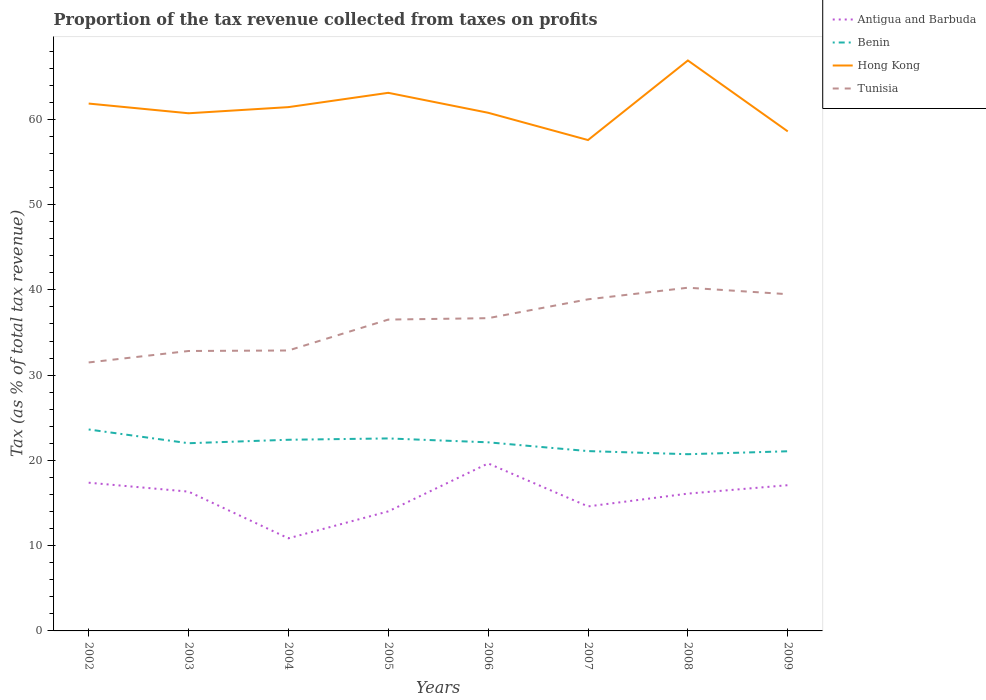Across all years, what is the maximum proportion of the tax revenue collected in Antigua and Barbuda?
Offer a very short reply. 10.86. In which year was the proportion of the tax revenue collected in Benin maximum?
Your response must be concise. 2008. What is the total proportion of the tax revenue collected in Hong Kong in the graph?
Your answer should be compact. 3.26. What is the difference between the highest and the second highest proportion of the tax revenue collected in Hong Kong?
Offer a terse response. 9.33. What is the difference between the highest and the lowest proportion of the tax revenue collected in Hong Kong?
Your answer should be very brief. 4. Is the proportion of the tax revenue collected in Antigua and Barbuda strictly greater than the proportion of the tax revenue collected in Hong Kong over the years?
Offer a terse response. Yes. How many years are there in the graph?
Provide a short and direct response. 8. Does the graph contain any zero values?
Make the answer very short. No. Where does the legend appear in the graph?
Provide a short and direct response. Top right. How many legend labels are there?
Your answer should be very brief. 4. How are the legend labels stacked?
Ensure brevity in your answer.  Vertical. What is the title of the graph?
Offer a very short reply. Proportion of the tax revenue collected from taxes on profits. Does "Armenia" appear as one of the legend labels in the graph?
Offer a terse response. No. What is the label or title of the X-axis?
Give a very brief answer. Years. What is the label or title of the Y-axis?
Your answer should be compact. Tax (as % of total tax revenue). What is the Tax (as % of total tax revenue) in Antigua and Barbuda in 2002?
Make the answer very short. 17.38. What is the Tax (as % of total tax revenue) of Benin in 2002?
Ensure brevity in your answer.  23.63. What is the Tax (as % of total tax revenue) in Hong Kong in 2002?
Your answer should be compact. 61.85. What is the Tax (as % of total tax revenue) in Tunisia in 2002?
Give a very brief answer. 31.49. What is the Tax (as % of total tax revenue) of Antigua and Barbuda in 2003?
Offer a terse response. 16.34. What is the Tax (as % of total tax revenue) of Benin in 2003?
Ensure brevity in your answer.  22.01. What is the Tax (as % of total tax revenue) in Hong Kong in 2003?
Provide a short and direct response. 60.71. What is the Tax (as % of total tax revenue) of Tunisia in 2003?
Ensure brevity in your answer.  32.83. What is the Tax (as % of total tax revenue) in Antigua and Barbuda in 2004?
Ensure brevity in your answer.  10.86. What is the Tax (as % of total tax revenue) in Benin in 2004?
Make the answer very short. 22.42. What is the Tax (as % of total tax revenue) in Hong Kong in 2004?
Offer a very short reply. 61.43. What is the Tax (as % of total tax revenue) of Tunisia in 2004?
Ensure brevity in your answer.  32.89. What is the Tax (as % of total tax revenue) in Antigua and Barbuda in 2005?
Your response must be concise. 14.02. What is the Tax (as % of total tax revenue) of Benin in 2005?
Your answer should be very brief. 22.58. What is the Tax (as % of total tax revenue) of Hong Kong in 2005?
Your response must be concise. 63.11. What is the Tax (as % of total tax revenue) in Tunisia in 2005?
Make the answer very short. 36.51. What is the Tax (as % of total tax revenue) in Antigua and Barbuda in 2006?
Your response must be concise. 19.64. What is the Tax (as % of total tax revenue) in Benin in 2006?
Your answer should be compact. 22.12. What is the Tax (as % of total tax revenue) in Hong Kong in 2006?
Your answer should be very brief. 60.77. What is the Tax (as % of total tax revenue) in Tunisia in 2006?
Your answer should be very brief. 36.68. What is the Tax (as % of total tax revenue) of Antigua and Barbuda in 2007?
Make the answer very short. 14.6. What is the Tax (as % of total tax revenue) in Benin in 2007?
Provide a short and direct response. 21.09. What is the Tax (as % of total tax revenue) in Hong Kong in 2007?
Ensure brevity in your answer.  57.57. What is the Tax (as % of total tax revenue) in Tunisia in 2007?
Keep it short and to the point. 38.89. What is the Tax (as % of total tax revenue) of Antigua and Barbuda in 2008?
Ensure brevity in your answer.  16.1. What is the Tax (as % of total tax revenue) of Benin in 2008?
Offer a terse response. 20.73. What is the Tax (as % of total tax revenue) of Hong Kong in 2008?
Your answer should be very brief. 66.9. What is the Tax (as % of total tax revenue) in Tunisia in 2008?
Your answer should be compact. 40.25. What is the Tax (as % of total tax revenue) of Antigua and Barbuda in 2009?
Keep it short and to the point. 17.09. What is the Tax (as % of total tax revenue) in Benin in 2009?
Your answer should be very brief. 21.07. What is the Tax (as % of total tax revenue) in Hong Kong in 2009?
Your answer should be very brief. 58.59. What is the Tax (as % of total tax revenue) of Tunisia in 2009?
Provide a short and direct response. 39.49. Across all years, what is the maximum Tax (as % of total tax revenue) in Antigua and Barbuda?
Your answer should be very brief. 19.64. Across all years, what is the maximum Tax (as % of total tax revenue) in Benin?
Make the answer very short. 23.63. Across all years, what is the maximum Tax (as % of total tax revenue) in Hong Kong?
Offer a very short reply. 66.9. Across all years, what is the maximum Tax (as % of total tax revenue) in Tunisia?
Offer a very short reply. 40.25. Across all years, what is the minimum Tax (as % of total tax revenue) in Antigua and Barbuda?
Your response must be concise. 10.86. Across all years, what is the minimum Tax (as % of total tax revenue) of Benin?
Keep it short and to the point. 20.73. Across all years, what is the minimum Tax (as % of total tax revenue) in Hong Kong?
Your response must be concise. 57.57. Across all years, what is the minimum Tax (as % of total tax revenue) in Tunisia?
Provide a succinct answer. 31.49. What is the total Tax (as % of total tax revenue) of Antigua and Barbuda in the graph?
Offer a very short reply. 126.05. What is the total Tax (as % of total tax revenue) in Benin in the graph?
Offer a very short reply. 175.64. What is the total Tax (as % of total tax revenue) of Hong Kong in the graph?
Ensure brevity in your answer.  490.93. What is the total Tax (as % of total tax revenue) in Tunisia in the graph?
Your answer should be compact. 289.03. What is the difference between the Tax (as % of total tax revenue) of Antigua and Barbuda in 2002 and that in 2003?
Provide a succinct answer. 1.05. What is the difference between the Tax (as % of total tax revenue) of Benin in 2002 and that in 2003?
Your answer should be very brief. 1.61. What is the difference between the Tax (as % of total tax revenue) of Hong Kong in 2002 and that in 2003?
Give a very brief answer. 1.14. What is the difference between the Tax (as % of total tax revenue) in Tunisia in 2002 and that in 2003?
Make the answer very short. -1.34. What is the difference between the Tax (as % of total tax revenue) of Antigua and Barbuda in 2002 and that in 2004?
Offer a terse response. 6.52. What is the difference between the Tax (as % of total tax revenue) in Benin in 2002 and that in 2004?
Keep it short and to the point. 1.21. What is the difference between the Tax (as % of total tax revenue) in Hong Kong in 2002 and that in 2004?
Keep it short and to the point. 0.42. What is the difference between the Tax (as % of total tax revenue) of Tunisia in 2002 and that in 2004?
Ensure brevity in your answer.  -1.4. What is the difference between the Tax (as % of total tax revenue) of Antigua and Barbuda in 2002 and that in 2005?
Provide a succinct answer. 3.36. What is the difference between the Tax (as % of total tax revenue) in Benin in 2002 and that in 2005?
Offer a very short reply. 1.05. What is the difference between the Tax (as % of total tax revenue) in Hong Kong in 2002 and that in 2005?
Give a very brief answer. -1.26. What is the difference between the Tax (as % of total tax revenue) of Tunisia in 2002 and that in 2005?
Give a very brief answer. -5.03. What is the difference between the Tax (as % of total tax revenue) of Antigua and Barbuda in 2002 and that in 2006?
Provide a succinct answer. -2.26. What is the difference between the Tax (as % of total tax revenue) of Benin in 2002 and that in 2006?
Offer a very short reply. 1.51. What is the difference between the Tax (as % of total tax revenue) of Hong Kong in 2002 and that in 2006?
Offer a terse response. 1.08. What is the difference between the Tax (as % of total tax revenue) in Tunisia in 2002 and that in 2006?
Your answer should be compact. -5.19. What is the difference between the Tax (as % of total tax revenue) of Antigua and Barbuda in 2002 and that in 2007?
Your response must be concise. 2.78. What is the difference between the Tax (as % of total tax revenue) of Benin in 2002 and that in 2007?
Offer a very short reply. 2.54. What is the difference between the Tax (as % of total tax revenue) in Hong Kong in 2002 and that in 2007?
Your answer should be compact. 4.28. What is the difference between the Tax (as % of total tax revenue) in Tunisia in 2002 and that in 2007?
Give a very brief answer. -7.4. What is the difference between the Tax (as % of total tax revenue) in Antigua and Barbuda in 2002 and that in 2008?
Keep it short and to the point. 1.28. What is the difference between the Tax (as % of total tax revenue) in Benin in 2002 and that in 2008?
Ensure brevity in your answer.  2.9. What is the difference between the Tax (as % of total tax revenue) in Hong Kong in 2002 and that in 2008?
Your answer should be compact. -5.05. What is the difference between the Tax (as % of total tax revenue) of Tunisia in 2002 and that in 2008?
Keep it short and to the point. -8.77. What is the difference between the Tax (as % of total tax revenue) in Antigua and Barbuda in 2002 and that in 2009?
Offer a very short reply. 0.29. What is the difference between the Tax (as % of total tax revenue) in Benin in 2002 and that in 2009?
Keep it short and to the point. 2.56. What is the difference between the Tax (as % of total tax revenue) in Hong Kong in 2002 and that in 2009?
Your answer should be very brief. 3.26. What is the difference between the Tax (as % of total tax revenue) of Tunisia in 2002 and that in 2009?
Offer a very short reply. -8. What is the difference between the Tax (as % of total tax revenue) of Antigua and Barbuda in 2003 and that in 2004?
Make the answer very short. 5.47. What is the difference between the Tax (as % of total tax revenue) in Benin in 2003 and that in 2004?
Offer a terse response. -0.41. What is the difference between the Tax (as % of total tax revenue) in Hong Kong in 2003 and that in 2004?
Keep it short and to the point. -0.72. What is the difference between the Tax (as % of total tax revenue) in Tunisia in 2003 and that in 2004?
Offer a very short reply. -0.06. What is the difference between the Tax (as % of total tax revenue) of Antigua and Barbuda in 2003 and that in 2005?
Provide a short and direct response. 2.31. What is the difference between the Tax (as % of total tax revenue) of Benin in 2003 and that in 2005?
Offer a very short reply. -0.56. What is the difference between the Tax (as % of total tax revenue) in Hong Kong in 2003 and that in 2005?
Provide a short and direct response. -2.4. What is the difference between the Tax (as % of total tax revenue) of Tunisia in 2003 and that in 2005?
Your answer should be very brief. -3.68. What is the difference between the Tax (as % of total tax revenue) in Antigua and Barbuda in 2003 and that in 2006?
Make the answer very short. -3.31. What is the difference between the Tax (as % of total tax revenue) of Benin in 2003 and that in 2006?
Ensure brevity in your answer.  -0.11. What is the difference between the Tax (as % of total tax revenue) of Hong Kong in 2003 and that in 2006?
Ensure brevity in your answer.  -0.06. What is the difference between the Tax (as % of total tax revenue) of Tunisia in 2003 and that in 2006?
Your answer should be very brief. -3.85. What is the difference between the Tax (as % of total tax revenue) in Antigua and Barbuda in 2003 and that in 2007?
Offer a very short reply. 1.73. What is the difference between the Tax (as % of total tax revenue) in Benin in 2003 and that in 2007?
Give a very brief answer. 0.92. What is the difference between the Tax (as % of total tax revenue) in Hong Kong in 2003 and that in 2007?
Keep it short and to the point. 3.14. What is the difference between the Tax (as % of total tax revenue) of Tunisia in 2003 and that in 2007?
Provide a short and direct response. -6.06. What is the difference between the Tax (as % of total tax revenue) in Antigua and Barbuda in 2003 and that in 2008?
Your answer should be very brief. 0.23. What is the difference between the Tax (as % of total tax revenue) of Benin in 2003 and that in 2008?
Your answer should be compact. 1.29. What is the difference between the Tax (as % of total tax revenue) in Hong Kong in 2003 and that in 2008?
Provide a succinct answer. -6.19. What is the difference between the Tax (as % of total tax revenue) in Tunisia in 2003 and that in 2008?
Offer a very short reply. -7.42. What is the difference between the Tax (as % of total tax revenue) in Antigua and Barbuda in 2003 and that in 2009?
Make the answer very short. -0.75. What is the difference between the Tax (as % of total tax revenue) of Benin in 2003 and that in 2009?
Your response must be concise. 0.94. What is the difference between the Tax (as % of total tax revenue) of Hong Kong in 2003 and that in 2009?
Keep it short and to the point. 2.13. What is the difference between the Tax (as % of total tax revenue) in Tunisia in 2003 and that in 2009?
Keep it short and to the point. -6.66. What is the difference between the Tax (as % of total tax revenue) in Antigua and Barbuda in 2004 and that in 2005?
Ensure brevity in your answer.  -3.16. What is the difference between the Tax (as % of total tax revenue) of Benin in 2004 and that in 2005?
Your answer should be very brief. -0.16. What is the difference between the Tax (as % of total tax revenue) in Hong Kong in 2004 and that in 2005?
Provide a succinct answer. -1.68. What is the difference between the Tax (as % of total tax revenue) in Tunisia in 2004 and that in 2005?
Keep it short and to the point. -3.62. What is the difference between the Tax (as % of total tax revenue) of Antigua and Barbuda in 2004 and that in 2006?
Your answer should be compact. -8.78. What is the difference between the Tax (as % of total tax revenue) in Benin in 2004 and that in 2006?
Offer a terse response. 0.3. What is the difference between the Tax (as % of total tax revenue) of Hong Kong in 2004 and that in 2006?
Your answer should be compact. 0.66. What is the difference between the Tax (as % of total tax revenue) of Tunisia in 2004 and that in 2006?
Provide a succinct answer. -3.79. What is the difference between the Tax (as % of total tax revenue) of Antigua and Barbuda in 2004 and that in 2007?
Make the answer very short. -3.74. What is the difference between the Tax (as % of total tax revenue) in Benin in 2004 and that in 2007?
Ensure brevity in your answer.  1.33. What is the difference between the Tax (as % of total tax revenue) of Hong Kong in 2004 and that in 2007?
Make the answer very short. 3.86. What is the difference between the Tax (as % of total tax revenue) of Tunisia in 2004 and that in 2007?
Your response must be concise. -6. What is the difference between the Tax (as % of total tax revenue) in Antigua and Barbuda in 2004 and that in 2008?
Your answer should be compact. -5.24. What is the difference between the Tax (as % of total tax revenue) of Benin in 2004 and that in 2008?
Provide a succinct answer. 1.69. What is the difference between the Tax (as % of total tax revenue) in Hong Kong in 2004 and that in 2008?
Your response must be concise. -5.47. What is the difference between the Tax (as % of total tax revenue) of Tunisia in 2004 and that in 2008?
Your answer should be compact. -7.36. What is the difference between the Tax (as % of total tax revenue) in Antigua and Barbuda in 2004 and that in 2009?
Your answer should be compact. -6.23. What is the difference between the Tax (as % of total tax revenue) of Benin in 2004 and that in 2009?
Keep it short and to the point. 1.35. What is the difference between the Tax (as % of total tax revenue) in Hong Kong in 2004 and that in 2009?
Offer a very short reply. 2.85. What is the difference between the Tax (as % of total tax revenue) of Tunisia in 2004 and that in 2009?
Provide a succinct answer. -6.6. What is the difference between the Tax (as % of total tax revenue) of Antigua and Barbuda in 2005 and that in 2006?
Give a very brief answer. -5.62. What is the difference between the Tax (as % of total tax revenue) in Benin in 2005 and that in 2006?
Provide a succinct answer. 0.46. What is the difference between the Tax (as % of total tax revenue) in Hong Kong in 2005 and that in 2006?
Ensure brevity in your answer.  2.34. What is the difference between the Tax (as % of total tax revenue) in Tunisia in 2005 and that in 2006?
Make the answer very short. -0.17. What is the difference between the Tax (as % of total tax revenue) of Antigua and Barbuda in 2005 and that in 2007?
Your answer should be compact. -0.58. What is the difference between the Tax (as % of total tax revenue) in Benin in 2005 and that in 2007?
Give a very brief answer. 1.48. What is the difference between the Tax (as % of total tax revenue) in Hong Kong in 2005 and that in 2007?
Your answer should be compact. 5.54. What is the difference between the Tax (as % of total tax revenue) of Tunisia in 2005 and that in 2007?
Make the answer very short. -2.38. What is the difference between the Tax (as % of total tax revenue) of Antigua and Barbuda in 2005 and that in 2008?
Give a very brief answer. -2.08. What is the difference between the Tax (as % of total tax revenue) of Benin in 2005 and that in 2008?
Keep it short and to the point. 1.85. What is the difference between the Tax (as % of total tax revenue) in Hong Kong in 2005 and that in 2008?
Provide a succinct answer. -3.79. What is the difference between the Tax (as % of total tax revenue) in Tunisia in 2005 and that in 2008?
Ensure brevity in your answer.  -3.74. What is the difference between the Tax (as % of total tax revenue) of Antigua and Barbuda in 2005 and that in 2009?
Make the answer very short. -3.07. What is the difference between the Tax (as % of total tax revenue) of Benin in 2005 and that in 2009?
Offer a very short reply. 1.51. What is the difference between the Tax (as % of total tax revenue) of Hong Kong in 2005 and that in 2009?
Provide a short and direct response. 4.52. What is the difference between the Tax (as % of total tax revenue) in Tunisia in 2005 and that in 2009?
Make the answer very short. -2.98. What is the difference between the Tax (as % of total tax revenue) in Antigua and Barbuda in 2006 and that in 2007?
Offer a very short reply. 5.04. What is the difference between the Tax (as % of total tax revenue) of Benin in 2006 and that in 2007?
Make the answer very short. 1.03. What is the difference between the Tax (as % of total tax revenue) in Hong Kong in 2006 and that in 2007?
Make the answer very short. 3.2. What is the difference between the Tax (as % of total tax revenue) in Tunisia in 2006 and that in 2007?
Your answer should be compact. -2.21. What is the difference between the Tax (as % of total tax revenue) of Antigua and Barbuda in 2006 and that in 2008?
Provide a short and direct response. 3.54. What is the difference between the Tax (as % of total tax revenue) in Benin in 2006 and that in 2008?
Provide a succinct answer. 1.39. What is the difference between the Tax (as % of total tax revenue) in Hong Kong in 2006 and that in 2008?
Make the answer very short. -6.13. What is the difference between the Tax (as % of total tax revenue) in Tunisia in 2006 and that in 2008?
Keep it short and to the point. -3.57. What is the difference between the Tax (as % of total tax revenue) of Antigua and Barbuda in 2006 and that in 2009?
Make the answer very short. 2.55. What is the difference between the Tax (as % of total tax revenue) of Benin in 2006 and that in 2009?
Offer a terse response. 1.05. What is the difference between the Tax (as % of total tax revenue) in Hong Kong in 2006 and that in 2009?
Provide a succinct answer. 2.18. What is the difference between the Tax (as % of total tax revenue) in Tunisia in 2006 and that in 2009?
Provide a succinct answer. -2.81. What is the difference between the Tax (as % of total tax revenue) in Antigua and Barbuda in 2007 and that in 2008?
Your answer should be very brief. -1.5. What is the difference between the Tax (as % of total tax revenue) of Benin in 2007 and that in 2008?
Your answer should be compact. 0.37. What is the difference between the Tax (as % of total tax revenue) in Hong Kong in 2007 and that in 2008?
Your answer should be compact. -9.33. What is the difference between the Tax (as % of total tax revenue) in Tunisia in 2007 and that in 2008?
Ensure brevity in your answer.  -1.36. What is the difference between the Tax (as % of total tax revenue) in Antigua and Barbuda in 2007 and that in 2009?
Keep it short and to the point. -2.49. What is the difference between the Tax (as % of total tax revenue) of Benin in 2007 and that in 2009?
Make the answer very short. 0.02. What is the difference between the Tax (as % of total tax revenue) of Hong Kong in 2007 and that in 2009?
Give a very brief answer. -1.02. What is the difference between the Tax (as % of total tax revenue) of Tunisia in 2007 and that in 2009?
Offer a terse response. -0.6. What is the difference between the Tax (as % of total tax revenue) in Antigua and Barbuda in 2008 and that in 2009?
Your answer should be compact. -0.99. What is the difference between the Tax (as % of total tax revenue) in Benin in 2008 and that in 2009?
Ensure brevity in your answer.  -0.34. What is the difference between the Tax (as % of total tax revenue) in Hong Kong in 2008 and that in 2009?
Offer a very short reply. 8.32. What is the difference between the Tax (as % of total tax revenue) of Tunisia in 2008 and that in 2009?
Give a very brief answer. 0.76. What is the difference between the Tax (as % of total tax revenue) in Antigua and Barbuda in 2002 and the Tax (as % of total tax revenue) in Benin in 2003?
Provide a short and direct response. -4.63. What is the difference between the Tax (as % of total tax revenue) of Antigua and Barbuda in 2002 and the Tax (as % of total tax revenue) of Hong Kong in 2003?
Ensure brevity in your answer.  -43.33. What is the difference between the Tax (as % of total tax revenue) in Antigua and Barbuda in 2002 and the Tax (as % of total tax revenue) in Tunisia in 2003?
Your response must be concise. -15.45. What is the difference between the Tax (as % of total tax revenue) in Benin in 2002 and the Tax (as % of total tax revenue) in Hong Kong in 2003?
Ensure brevity in your answer.  -37.09. What is the difference between the Tax (as % of total tax revenue) of Benin in 2002 and the Tax (as % of total tax revenue) of Tunisia in 2003?
Offer a terse response. -9.2. What is the difference between the Tax (as % of total tax revenue) of Hong Kong in 2002 and the Tax (as % of total tax revenue) of Tunisia in 2003?
Keep it short and to the point. 29.02. What is the difference between the Tax (as % of total tax revenue) of Antigua and Barbuda in 2002 and the Tax (as % of total tax revenue) of Benin in 2004?
Make the answer very short. -5.04. What is the difference between the Tax (as % of total tax revenue) in Antigua and Barbuda in 2002 and the Tax (as % of total tax revenue) in Hong Kong in 2004?
Your response must be concise. -44.05. What is the difference between the Tax (as % of total tax revenue) of Antigua and Barbuda in 2002 and the Tax (as % of total tax revenue) of Tunisia in 2004?
Your response must be concise. -15.51. What is the difference between the Tax (as % of total tax revenue) in Benin in 2002 and the Tax (as % of total tax revenue) in Hong Kong in 2004?
Give a very brief answer. -37.81. What is the difference between the Tax (as % of total tax revenue) of Benin in 2002 and the Tax (as % of total tax revenue) of Tunisia in 2004?
Keep it short and to the point. -9.26. What is the difference between the Tax (as % of total tax revenue) of Hong Kong in 2002 and the Tax (as % of total tax revenue) of Tunisia in 2004?
Give a very brief answer. 28.96. What is the difference between the Tax (as % of total tax revenue) of Antigua and Barbuda in 2002 and the Tax (as % of total tax revenue) of Benin in 2005?
Keep it short and to the point. -5.19. What is the difference between the Tax (as % of total tax revenue) in Antigua and Barbuda in 2002 and the Tax (as % of total tax revenue) in Hong Kong in 2005?
Your response must be concise. -45.73. What is the difference between the Tax (as % of total tax revenue) in Antigua and Barbuda in 2002 and the Tax (as % of total tax revenue) in Tunisia in 2005?
Offer a terse response. -19.13. What is the difference between the Tax (as % of total tax revenue) of Benin in 2002 and the Tax (as % of total tax revenue) of Hong Kong in 2005?
Provide a succinct answer. -39.48. What is the difference between the Tax (as % of total tax revenue) of Benin in 2002 and the Tax (as % of total tax revenue) of Tunisia in 2005?
Offer a very short reply. -12.89. What is the difference between the Tax (as % of total tax revenue) of Hong Kong in 2002 and the Tax (as % of total tax revenue) of Tunisia in 2005?
Your response must be concise. 25.33. What is the difference between the Tax (as % of total tax revenue) in Antigua and Barbuda in 2002 and the Tax (as % of total tax revenue) in Benin in 2006?
Keep it short and to the point. -4.74. What is the difference between the Tax (as % of total tax revenue) of Antigua and Barbuda in 2002 and the Tax (as % of total tax revenue) of Hong Kong in 2006?
Offer a terse response. -43.39. What is the difference between the Tax (as % of total tax revenue) in Antigua and Barbuda in 2002 and the Tax (as % of total tax revenue) in Tunisia in 2006?
Your answer should be very brief. -19.3. What is the difference between the Tax (as % of total tax revenue) of Benin in 2002 and the Tax (as % of total tax revenue) of Hong Kong in 2006?
Provide a succinct answer. -37.14. What is the difference between the Tax (as % of total tax revenue) of Benin in 2002 and the Tax (as % of total tax revenue) of Tunisia in 2006?
Ensure brevity in your answer.  -13.05. What is the difference between the Tax (as % of total tax revenue) in Hong Kong in 2002 and the Tax (as % of total tax revenue) in Tunisia in 2006?
Provide a succinct answer. 25.17. What is the difference between the Tax (as % of total tax revenue) of Antigua and Barbuda in 2002 and the Tax (as % of total tax revenue) of Benin in 2007?
Your answer should be compact. -3.71. What is the difference between the Tax (as % of total tax revenue) of Antigua and Barbuda in 2002 and the Tax (as % of total tax revenue) of Hong Kong in 2007?
Give a very brief answer. -40.19. What is the difference between the Tax (as % of total tax revenue) of Antigua and Barbuda in 2002 and the Tax (as % of total tax revenue) of Tunisia in 2007?
Keep it short and to the point. -21.51. What is the difference between the Tax (as % of total tax revenue) of Benin in 2002 and the Tax (as % of total tax revenue) of Hong Kong in 2007?
Give a very brief answer. -33.94. What is the difference between the Tax (as % of total tax revenue) of Benin in 2002 and the Tax (as % of total tax revenue) of Tunisia in 2007?
Your answer should be compact. -15.26. What is the difference between the Tax (as % of total tax revenue) of Hong Kong in 2002 and the Tax (as % of total tax revenue) of Tunisia in 2007?
Your response must be concise. 22.96. What is the difference between the Tax (as % of total tax revenue) of Antigua and Barbuda in 2002 and the Tax (as % of total tax revenue) of Benin in 2008?
Give a very brief answer. -3.34. What is the difference between the Tax (as % of total tax revenue) in Antigua and Barbuda in 2002 and the Tax (as % of total tax revenue) in Hong Kong in 2008?
Give a very brief answer. -49.52. What is the difference between the Tax (as % of total tax revenue) in Antigua and Barbuda in 2002 and the Tax (as % of total tax revenue) in Tunisia in 2008?
Your response must be concise. -22.87. What is the difference between the Tax (as % of total tax revenue) in Benin in 2002 and the Tax (as % of total tax revenue) in Hong Kong in 2008?
Offer a terse response. -43.28. What is the difference between the Tax (as % of total tax revenue) of Benin in 2002 and the Tax (as % of total tax revenue) of Tunisia in 2008?
Give a very brief answer. -16.63. What is the difference between the Tax (as % of total tax revenue) in Hong Kong in 2002 and the Tax (as % of total tax revenue) in Tunisia in 2008?
Make the answer very short. 21.6. What is the difference between the Tax (as % of total tax revenue) in Antigua and Barbuda in 2002 and the Tax (as % of total tax revenue) in Benin in 2009?
Make the answer very short. -3.69. What is the difference between the Tax (as % of total tax revenue) in Antigua and Barbuda in 2002 and the Tax (as % of total tax revenue) in Hong Kong in 2009?
Give a very brief answer. -41.2. What is the difference between the Tax (as % of total tax revenue) of Antigua and Barbuda in 2002 and the Tax (as % of total tax revenue) of Tunisia in 2009?
Provide a succinct answer. -22.11. What is the difference between the Tax (as % of total tax revenue) of Benin in 2002 and the Tax (as % of total tax revenue) of Hong Kong in 2009?
Your response must be concise. -34.96. What is the difference between the Tax (as % of total tax revenue) in Benin in 2002 and the Tax (as % of total tax revenue) in Tunisia in 2009?
Keep it short and to the point. -15.86. What is the difference between the Tax (as % of total tax revenue) of Hong Kong in 2002 and the Tax (as % of total tax revenue) of Tunisia in 2009?
Your answer should be very brief. 22.36. What is the difference between the Tax (as % of total tax revenue) in Antigua and Barbuda in 2003 and the Tax (as % of total tax revenue) in Benin in 2004?
Give a very brief answer. -6.08. What is the difference between the Tax (as % of total tax revenue) of Antigua and Barbuda in 2003 and the Tax (as % of total tax revenue) of Hong Kong in 2004?
Provide a succinct answer. -45.1. What is the difference between the Tax (as % of total tax revenue) of Antigua and Barbuda in 2003 and the Tax (as % of total tax revenue) of Tunisia in 2004?
Your answer should be very brief. -16.55. What is the difference between the Tax (as % of total tax revenue) of Benin in 2003 and the Tax (as % of total tax revenue) of Hong Kong in 2004?
Make the answer very short. -39.42. What is the difference between the Tax (as % of total tax revenue) in Benin in 2003 and the Tax (as % of total tax revenue) in Tunisia in 2004?
Your response must be concise. -10.88. What is the difference between the Tax (as % of total tax revenue) in Hong Kong in 2003 and the Tax (as % of total tax revenue) in Tunisia in 2004?
Make the answer very short. 27.82. What is the difference between the Tax (as % of total tax revenue) in Antigua and Barbuda in 2003 and the Tax (as % of total tax revenue) in Benin in 2005?
Make the answer very short. -6.24. What is the difference between the Tax (as % of total tax revenue) in Antigua and Barbuda in 2003 and the Tax (as % of total tax revenue) in Hong Kong in 2005?
Your response must be concise. -46.77. What is the difference between the Tax (as % of total tax revenue) of Antigua and Barbuda in 2003 and the Tax (as % of total tax revenue) of Tunisia in 2005?
Give a very brief answer. -20.18. What is the difference between the Tax (as % of total tax revenue) in Benin in 2003 and the Tax (as % of total tax revenue) in Hong Kong in 2005?
Your response must be concise. -41.1. What is the difference between the Tax (as % of total tax revenue) in Benin in 2003 and the Tax (as % of total tax revenue) in Tunisia in 2005?
Your response must be concise. -14.5. What is the difference between the Tax (as % of total tax revenue) of Hong Kong in 2003 and the Tax (as % of total tax revenue) of Tunisia in 2005?
Provide a short and direct response. 24.2. What is the difference between the Tax (as % of total tax revenue) of Antigua and Barbuda in 2003 and the Tax (as % of total tax revenue) of Benin in 2006?
Make the answer very short. -5.78. What is the difference between the Tax (as % of total tax revenue) of Antigua and Barbuda in 2003 and the Tax (as % of total tax revenue) of Hong Kong in 2006?
Offer a very short reply. -44.43. What is the difference between the Tax (as % of total tax revenue) of Antigua and Barbuda in 2003 and the Tax (as % of total tax revenue) of Tunisia in 2006?
Make the answer very short. -20.34. What is the difference between the Tax (as % of total tax revenue) in Benin in 2003 and the Tax (as % of total tax revenue) in Hong Kong in 2006?
Ensure brevity in your answer.  -38.76. What is the difference between the Tax (as % of total tax revenue) in Benin in 2003 and the Tax (as % of total tax revenue) in Tunisia in 2006?
Provide a short and direct response. -14.67. What is the difference between the Tax (as % of total tax revenue) of Hong Kong in 2003 and the Tax (as % of total tax revenue) of Tunisia in 2006?
Your answer should be very brief. 24.03. What is the difference between the Tax (as % of total tax revenue) in Antigua and Barbuda in 2003 and the Tax (as % of total tax revenue) in Benin in 2007?
Your response must be concise. -4.75. What is the difference between the Tax (as % of total tax revenue) of Antigua and Barbuda in 2003 and the Tax (as % of total tax revenue) of Hong Kong in 2007?
Your answer should be compact. -41.23. What is the difference between the Tax (as % of total tax revenue) in Antigua and Barbuda in 2003 and the Tax (as % of total tax revenue) in Tunisia in 2007?
Provide a succinct answer. -22.55. What is the difference between the Tax (as % of total tax revenue) in Benin in 2003 and the Tax (as % of total tax revenue) in Hong Kong in 2007?
Give a very brief answer. -35.56. What is the difference between the Tax (as % of total tax revenue) of Benin in 2003 and the Tax (as % of total tax revenue) of Tunisia in 2007?
Ensure brevity in your answer.  -16.88. What is the difference between the Tax (as % of total tax revenue) in Hong Kong in 2003 and the Tax (as % of total tax revenue) in Tunisia in 2007?
Your answer should be very brief. 21.82. What is the difference between the Tax (as % of total tax revenue) in Antigua and Barbuda in 2003 and the Tax (as % of total tax revenue) in Benin in 2008?
Ensure brevity in your answer.  -4.39. What is the difference between the Tax (as % of total tax revenue) of Antigua and Barbuda in 2003 and the Tax (as % of total tax revenue) of Hong Kong in 2008?
Provide a succinct answer. -50.57. What is the difference between the Tax (as % of total tax revenue) of Antigua and Barbuda in 2003 and the Tax (as % of total tax revenue) of Tunisia in 2008?
Provide a succinct answer. -23.92. What is the difference between the Tax (as % of total tax revenue) in Benin in 2003 and the Tax (as % of total tax revenue) in Hong Kong in 2008?
Make the answer very short. -44.89. What is the difference between the Tax (as % of total tax revenue) of Benin in 2003 and the Tax (as % of total tax revenue) of Tunisia in 2008?
Provide a succinct answer. -18.24. What is the difference between the Tax (as % of total tax revenue) in Hong Kong in 2003 and the Tax (as % of total tax revenue) in Tunisia in 2008?
Give a very brief answer. 20.46. What is the difference between the Tax (as % of total tax revenue) of Antigua and Barbuda in 2003 and the Tax (as % of total tax revenue) of Benin in 2009?
Your response must be concise. -4.73. What is the difference between the Tax (as % of total tax revenue) in Antigua and Barbuda in 2003 and the Tax (as % of total tax revenue) in Hong Kong in 2009?
Ensure brevity in your answer.  -42.25. What is the difference between the Tax (as % of total tax revenue) of Antigua and Barbuda in 2003 and the Tax (as % of total tax revenue) of Tunisia in 2009?
Ensure brevity in your answer.  -23.15. What is the difference between the Tax (as % of total tax revenue) of Benin in 2003 and the Tax (as % of total tax revenue) of Hong Kong in 2009?
Offer a terse response. -36.57. What is the difference between the Tax (as % of total tax revenue) in Benin in 2003 and the Tax (as % of total tax revenue) in Tunisia in 2009?
Your answer should be very brief. -17.48. What is the difference between the Tax (as % of total tax revenue) in Hong Kong in 2003 and the Tax (as % of total tax revenue) in Tunisia in 2009?
Make the answer very short. 21.22. What is the difference between the Tax (as % of total tax revenue) of Antigua and Barbuda in 2004 and the Tax (as % of total tax revenue) of Benin in 2005?
Your answer should be very brief. -11.71. What is the difference between the Tax (as % of total tax revenue) of Antigua and Barbuda in 2004 and the Tax (as % of total tax revenue) of Hong Kong in 2005?
Ensure brevity in your answer.  -52.25. What is the difference between the Tax (as % of total tax revenue) in Antigua and Barbuda in 2004 and the Tax (as % of total tax revenue) in Tunisia in 2005?
Your answer should be very brief. -25.65. What is the difference between the Tax (as % of total tax revenue) in Benin in 2004 and the Tax (as % of total tax revenue) in Hong Kong in 2005?
Offer a very short reply. -40.69. What is the difference between the Tax (as % of total tax revenue) of Benin in 2004 and the Tax (as % of total tax revenue) of Tunisia in 2005?
Provide a short and direct response. -14.1. What is the difference between the Tax (as % of total tax revenue) of Hong Kong in 2004 and the Tax (as % of total tax revenue) of Tunisia in 2005?
Your response must be concise. 24.92. What is the difference between the Tax (as % of total tax revenue) in Antigua and Barbuda in 2004 and the Tax (as % of total tax revenue) in Benin in 2006?
Your answer should be compact. -11.26. What is the difference between the Tax (as % of total tax revenue) in Antigua and Barbuda in 2004 and the Tax (as % of total tax revenue) in Hong Kong in 2006?
Make the answer very short. -49.91. What is the difference between the Tax (as % of total tax revenue) in Antigua and Barbuda in 2004 and the Tax (as % of total tax revenue) in Tunisia in 2006?
Your response must be concise. -25.82. What is the difference between the Tax (as % of total tax revenue) of Benin in 2004 and the Tax (as % of total tax revenue) of Hong Kong in 2006?
Offer a very short reply. -38.35. What is the difference between the Tax (as % of total tax revenue) in Benin in 2004 and the Tax (as % of total tax revenue) in Tunisia in 2006?
Provide a short and direct response. -14.26. What is the difference between the Tax (as % of total tax revenue) in Hong Kong in 2004 and the Tax (as % of total tax revenue) in Tunisia in 2006?
Make the answer very short. 24.75. What is the difference between the Tax (as % of total tax revenue) in Antigua and Barbuda in 2004 and the Tax (as % of total tax revenue) in Benin in 2007?
Your answer should be very brief. -10.23. What is the difference between the Tax (as % of total tax revenue) of Antigua and Barbuda in 2004 and the Tax (as % of total tax revenue) of Hong Kong in 2007?
Give a very brief answer. -46.71. What is the difference between the Tax (as % of total tax revenue) in Antigua and Barbuda in 2004 and the Tax (as % of total tax revenue) in Tunisia in 2007?
Keep it short and to the point. -28.03. What is the difference between the Tax (as % of total tax revenue) in Benin in 2004 and the Tax (as % of total tax revenue) in Hong Kong in 2007?
Your answer should be compact. -35.15. What is the difference between the Tax (as % of total tax revenue) in Benin in 2004 and the Tax (as % of total tax revenue) in Tunisia in 2007?
Ensure brevity in your answer.  -16.47. What is the difference between the Tax (as % of total tax revenue) of Hong Kong in 2004 and the Tax (as % of total tax revenue) of Tunisia in 2007?
Offer a terse response. 22.54. What is the difference between the Tax (as % of total tax revenue) in Antigua and Barbuda in 2004 and the Tax (as % of total tax revenue) in Benin in 2008?
Provide a succinct answer. -9.86. What is the difference between the Tax (as % of total tax revenue) in Antigua and Barbuda in 2004 and the Tax (as % of total tax revenue) in Hong Kong in 2008?
Provide a short and direct response. -56.04. What is the difference between the Tax (as % of total tax revenue) in Antigua and Barbuda in 2004 and the Tax (as % of total tax revenue) in Tunisia in 2008?
Make the answer very short. -29.39. What is the difference between the Tax (as % of total tax revenue) of Benin in 2004 and the Tax (as % of total tax revenue) of Hong Kong in 2008?
Your response must be concise. -44.48. What is the difference between the Tax (as % of total tax revenue) of Benin in 2004 and the Tax (as % of total tax revenue) of Tunisia in 2008?
Ensure brevity in your answer.  -17.83. What is the difference between the Tax (as % of total tax revenue) in Hong Kong in 2004 and the Tax (as % of total tax revenue) in Tunisia in 2008?
Give a very brief answer. 21.18. What is the difference between the Tax (as % of total tax revenue) in Antigua and Barbuda in 2004 and the Tax (as % of total tax revenue) in Benin in 2009?
Your response must be concise. -10.21. What is the difference between the Tax (as % of total tax revenue) of Antigua and Barbuda in 2004 and the Tax (as % of total tax revenue) of Hong Kong in 2009?
Ensure brevity in your answer.  -47.72. What is the difference between the Tax (as % of total tax revenue) in Antigua and Barbuda in 2004 and the Tax (as % of total tax revenue) in Tunisia in 2009?
Your answer should be compact. -28.63. What is the difference between the Tax (as % of total tax revenue) of Benin in 2004 and the Tax (as % of total tax revenue) of Hong Kong in 2009?
Offer a very short reply. -36.17. What is the difference between the Tax (as % of total tax revenue) in Benin in 2004 and the Tax (as % of total tax revenue) in Tunisia in 2009?
Your answer should be very brief. -17.07. What is the difference between the Tax (as % of total tax revenue) in Hong Kong in 2004 and the Tax (as % of total tax revenue) in Tunisia in 2009?
Provide a short and direct response. 21.94. What is the difference between the Tax (as % of total tax revenue) in Antigua and Barbuda in 2005 and the Tax (as % of total tax revenue) in Benin in 2006?
Offer a terse response. -8.1. What is the difference between the Tax (as % of total tax revenue) of Antigua and Barbuda in 2005 and the Tax (as % of total tax revenue) of Hong Kong in 2006?
Your answer should be compact. -46.75. What is the difference between the Tax (as % of total tax revenue) of Antigua and Barbuda in 2005 and the Tax (as % of total tax revenue) of Tunisia in 2006?
Your answer should be very brief. -22.66. What is the difference between the Tax (as % of total tax revenue) of Benin in 2005 and the Tax (as % of total tax revenue) of Hong Kong in 2006?
Your answer should be very brief. -38.19. What is the difference between the Tax (as % of total tax revenue) of Benin in 2005 and the Tax (as % of total tax revenue) of Tunisia in 2006?
Your answer should be very brief. -14.1. What is the difference between the Tax (as % of total tax revenue) in Hong Kong in 2005 and the Tax (as % of total tax revenue) in Tunisia in 2006?
Your answer should be compact. 26.43. What is the difference between the Tax (as % of total tax revenue) in Antigua and Barbuda in 2005 and the Tax (as % of total tax revenue) in Benin in 2007?
Make the answer very short. -7.07. What is the difference between the Tax (as % of total tax revenue) of Antigua and Barbuda in 2005 and the Tax (as % of total tax revenue) of Hong Kong in 2007?
Your response must be concise. -43.55. What is the difference between the Tax (as % of total tax revenue) of Antigua and Barbuda in 2005 and the Tax (as % of total tax revenue) of Tunisia in 2007?
Offer a terse response. -24.87. What is the difference between the Tax (as % of total tax revenue) of Benin in 2005 and the Tax (as % of total tax revenue) of Hong Kong in 2007?
Your answer should be very brief. -34.99. What is the difference between the Tax (as % of total tax revenue) in Benin in 2005 and the Tax (as % of total tax revenue) in Tunisia in 2007?
Give a very brief answer. -16.31. What is the difference between the Tax (as % of total tax revenue) of Hong Kong in 2005 and the Tax (as % of total tax revenue) of Tunisia in 2007?
Your response must be concise. 24.22. What is the difference between the Tax (as % of total tax revenue) in Antigua and Barbuda in 2005 and the Tax (as % of total tax revenue) in Benin in 2008?
Keep it short and to the point. -6.7. What is the difference between the Tax (as % of total tax revenue) in Antigua and Barbuda in 2005 and the Tax (as % of total tax revenue) in Hong Kong in 2008?
Provide a short and direct response. -52.88. What is the difference between the Tax (as % of total tax revenue) in Antigua and Barbuda in 2005 and the Tax (as % of total tax revenue) in Tunisia in 2008?
Provide a short and direct response. -26.23. What is the difference between the Tax (as % of total tax revenue) in Benin in 2005 and the Tax (as % of total tax revenue) in Hong Kong in 2008?
Your response must be concise. -44.33. What is the difference between the Tax (as % of total tax revenue) in Benin in 2005 and the Tax (as % of total tax revenue) in Tunisia in 2008?
Offer a very short reply. -17.68. What is the difference between the Tax (as % of total tax revenue) in Hong Kong in 2005 and the Tax (as % of total tax revenue) in Tunisia in 2008?
Offer a very short reply. 22.86. What is the difference between the Tax (as % of total tax revenue) in Antigua and Barbuda in 2005 and the Tax (as % of total tax revenue) in Benin in 2009?
Your answer should be very brief. -7.05. What is the difference between the Tax (as % of total tax revenue) of Antigua and Barbuda in 2005 and the Tax (as % of total tax revenue) of Hong Kong in 2009?
Give a very brief answer. -44.56. What is the difference between the Tax (as % of total tax revenue) in Antigua and Barbuda in 2005 and the Tax (as % of total tax revenue) in Tunisia in 2009?
Ensure brevity in your answer.  -25.47. What is the difference between the Tax (as % of total tax revenue) of Benin in 2005 and the Tax (as % of total tax revenue) of Hong Kong in 2009?
Give a very brief answer. -36.01. What is the difference between the Tax (as % of total tax revenue) in Benin in 2005 and the Tax (as % of total tax revenue) in Tunisia in 2009?
Offer a terse response. -16.91. What is the difference between the Tax (as % of total tax revenue) of Hong Kong in 2005 and the Tax (as % of total tax revenue) of Tunisia in 2009?
Provide a succinct answer. 23.62. What is the difference between the Tax (as % of total tax revenue) of Antigua and Barbuda in 2006 and the Tax (as % of total tax revenue) of Benin in 2007?
Provide a succinct answer. -1.45. What is the difference between the Tax (as % of total tax revenue) of Antigua and Barbuda in 2006 and the Tax (as % of total tax revenue) of Hong Kong in 2007?
Offer a very short reply. -37.93. What is the difference between the Tax (as % of total tax revenue) of Antigua and Barbuda in 2006 and the Tax (as % of total tax revenue) of Tunisia in 2007?
Provide a succinct answer. -19.25. What is the difference between the Tax (as % of total tax revenue) of Benin in 2006 and the Tax (as % of total tax revenue) of Hong Kong in 2007?
Your answer should be compact. -35.45. What is the difference between the Tax (as % of total tax revenue) of Benin in 2006 and the Tax (as % of total tax revenue) of Tunisia in 2007?
Give a very brief answer. -16.77. What is the difference between the Tax (as % of total tax revenue) of Hong Kong in 2006 and the Tax (as % of total tax revenue) of Tunisia in 2007?
Provide a short and direct response. 21.88. What is the difference between the Tax (as % of total tax revenue) of Antigua and Barbuda in 2006 and the Tax (as % of total tax revenue) of Benin in 2008?
Offer a very short reply. -1.08. What is the difference between the Tax (as % of total tax revenue) of Antigua and Barbuda in 2006 and the Tax (as % of total tax revenue) of Hong Kong in 2008?
Provide a succinct answer. -47.26. What is the difference between the Tax (as % of total tax revenue) of Antigua and Barbuda in 2006 and the Tax (as % of total tax revenue) of Tunisia in 2008?
Give a very brief answer. -20.61. What is the difference between the Tax (as % of total tax revenue) in Benin in 2006 and the Tax (as % of total tax revenue) in Hong Kong in 2008?
Keep it short and to the point. -44.78. What is the difference between the Tax (as % of total tax revenue) of Benin in 2006 and the Tax (as % of total tax revenue) of Tunisia in 2008?
Your answer should be very brief. -18.13. What is the difference between the Tax (as % of total tax revenue) in Hong Kong in 2006 and the Tax (as % of total tax revenue) in Tunisia in 2008?
Ensure brevity in your answer.  20.52. What is the difference between the Tax (as % of total tax revenue) of Antigua and Barbuda in 2006 and the Tax (as % of total tax revenue) of Benin in 2009?
Your response must be concise. -1.43. What is the difference between the Tax (as % of total tax revenue) of Antigua and Barbuda in 2006 and the Tax (as % of total tax revenue) of Hong Kong in 2009?
Give a very brief answer. -38.94. What is the difference between the Tax (as % of total tax revenue) in Antigua and Barbuda in 2006 and the Tax (as % of total tax revenue) in Tunisia in 2009?
Make the answer very short. -19.85. What is the difference between the Tax (as % of total tax revenue) of Benin in 2006 and the Tax (as % of total tax revenue) of Hong Kong in 2009?
Ensure brevity in your answer.  -36.47. What is the difference between the Tax (as % of total tax revenue) of Benin in 2006 and the Tax (as % of total tax revenue) of Tunisia in 2009?
Ensure brevity in your answer.  -17.37. What is the difference between the Tax (as % of total tax revenue) in Hong Kong in 2006 and the Tax (as % of total tax revenue) in Tunisia in 2009?
Make the answer very short. 21.28. What is the difference between the Tax (as % of total tax revenue) of Antigua and Barbuda in 2007 and the Tax (as % of total tax revenue) of Benin in 2008?
Give a very brief answer. -6.12. What is the difference between the Tax (as % of total tax revenue) of Antigua and Barbuda in 2007 and the Tax (as % of total tax revenue) of Hong Kong in 2008?
Provide a succinct answer. -52.3. What is the difference between the Tax (as % of total tax revenue) of Antigua and Barbuda in 2007 and the Tax (as % of total tax revenue) of Tunisia in 2008?
Your answer should be very brief. -25.65. What is the difference between the Tax (as % of total tax revenue) of Benin in 2007 and the Tax (as % of total tax revenue) of Hong Kong in 2008?
Ensure brevity in your answer.  -45.81. What is the difference between the Tax (as % of total tax revenue) of Benin in 2007 and the Tax (as % of total tax revenue) of Tunisia in 2008?
Your answer should be very brief. -19.16. What is the difference between the Tax (as % of total tax revenue) in Hong Kong in 2007 and the Tax (as % of total tax revenue) in Tunisia in 2008?
Your answer should be very brief. 17.32. What is the difference between the Tax (as % of total tax revenue) of Antigua and Barbuda in 2007 and the Tax (as % of total tax revenue) of Benin in 2009?
Provide a short and direct response. -6.47. What is the difference between the Tax (as % of total tax revenue) of Antigua and Barbuda in 2007 and the Tax (as % of total tax revenue) of Hong Kong in 2009?
Ensure brevity in your answer.  -43.98. What is the difference between the Tax (as % of total tax revenue) in Antigua and Barbuda in 2007 and the Tax (as % of total tax revenue) in Tunisia in 2009?
Your answer should be compact. -24.89. What is the difference between the Tax (as % of total tax revenue) in Benin in 2007 and the Tax (as % of total tax revenue) in Hong Kong in 2009?
Provide a short and direct response. -37.49. What is the difference between the Tax (as % of total tax revenue) in Benin in 2007 and the Tax (as % of total tax revenue) in Tunisia in 2009?
Offer a very short reply. -18.4. What is the difference between the Tax (as % of total tax revenue) of Hong Kong in 2007 and the Tax (as % of total tax revenue) of Tunisia in 2009?
Your answer should be compact. 18.08. What is the difference between the Tax (as % of total tax revenue) in Antigua and Barbuda in 2008 and the Tax (as % of total tax revenue) in Benin in 2009?
Ensure brevity in your answer.  -4.97. What is the difference between the Tax (as % of total tax revenue) in Antigua and Barbuda in 2008 and the Tax (as % of total tax revenue) in Hong Kong in 2009?
Provide a short and direct response. -42.48. What is the difference between the Tax (as % of total tax revenue) of Antigua and Barbuda in 2008 and the Tax (as % of total tax revenue) of Tunisia in 2009?
Provide a short and direct response. -23.39. What is the difference between the Tax (as % of total tax revenue) in Benin in 2008 and the Tax (as % of total tax revenue) in Hong Kong in 2009?
Offer a terse response. -37.86. What is the difference between the Tax (as % of total tax revenue) in Benin in 2008 and the Tax (as % of total tax revenue) in Tunisia in 2009?
Provide a succinct answer. -18.76. What is the difference between the Tax (as % of total tax revenue) in Hong Kong in 2008 and the Tax (as % of total tax revenue) in Tunisia in 2009?
Ensure brevity in your answer.  27.41. What is the average Tax (as % of total tax revenue) of Antigua and Barbuda per year?
Make the answer very short. 15.76. What is the average Tax (as % of total tax revenue) in Benin per year?
Your response must be concise. 21.95. What is the average Tax (as % of total tax revenue) in Hong Kong per year?
Give a very brief answer. 61.37. What is the average Tax (as % of total tax revenue) of Tunisia per year?
Give a very brief answer. 36.13. In the year 2002, what is the difference between the Tax (as % of total tax revenue) in Antigua and Barbuda and Tax (as % of total tax revenue) in Benin?
Offer a terse response. -6.24. In the year 2002, what is the difference between the Tax (as % of total tax revenue) of Antigua and Barbuda and Tax (as % of total tax revenue) of Hong Kong?
Offer a very short reply. -44.47. In the year 2002, what is the difference between the Tax (as % of total tax revenue) of Antigua and Barbuda and Tax (as % of total tax revenue) of Tunisia?
Your response must be concise. -14.1. In the year 2002, what is the difference between the Tax (as % of total tax revenue) in Benin and Tax (as % of total tax revenue) in Hong Kong?
Keep it short and to the point. -38.22. In the year 2002, what is the difference between the Tax (as % of total tax revenue) of Benin and Tax (as % of total tax revenue) of Tunisia?
Your answer should be very brief. -7.86. In the year 2002, what is the difference between the Tax (as % of total tax revenue) of Hong Kong and Tax (as % of total tax revenue) of Tunisia?
Offer a very short reply. 30.36. In the year 2003, what is the difference between the Tax (as % of total tax revenue) in Antigua and Barbuda and Tax (as % of total tax revenue) in Benin?
Your answer should be compact. -5.68. In the year 2003, what is the difference between the Tax (as % of total tax revenue) of Antigua and Barbuda and Tax (as % of total tax revenue) of Hong Kong?
Your answer should be compact. -44.38. In the year 2003, what is the difference between the Tax (as % of total tax revenue) in Antigua and Barbuda and Tax (as % of total tax revenue) in Tunisia?
Your answer should be compact. -16.49. In the year 2003, what is the difference between the Tax (as % of total tax revenue) of Benin and Tax (as % of total tax revenue) of Hong Kong?
Keep it short and to the point. -38.7. In the year 2003, what is the difference between the Tax (as % of total tax revenue) in Benin and Tax (as % of total tax revenue) in Tunisia?
Your answer should be very brief. -10.82. In the year 2003, what is the difference between the Tax (as % of total tax revenue) of Hong Kong and Tax (as % of total tax revenue) of Tunisia?
Ensure brevity in your answer.  27.88. In the year 2004, what is the difference between the Tax (as % of total tax revenue) in Antigua and Barbuda and Tax (as % of total tax revenue) in Benin?
Your answer should be very brief. -11.56. In the year 2004, what is the difference between the Tax (as % of total tax revenue) in Antigua and Barbuda and Tax (as % of total tax revenue) in Hong Kong?
Your answer should be compact. -50.57. In the year 2004, what is the difference between the Tax (as % of total tax revenue) of Antigua and Barbuda and Tax (as % of total tax revenue) of Tunisia?
Offer a very short reply. -22.03. In the year 2004, what is the difference between the Tax (as % of total tax revenue) in Benin and Tax (as % of total tax revenue) in Hong Kong?
Offer a terse response. -39.01. In the year 2004, what is the difference between the Tax (as % of total tax revenue) of Benin and Tax (as % of total tax revenue) of Tunisia?
Give a very brief answer. -10.47. In the year 2004, what is the difference between the Tax (as % of total tax revenue) in Hong Kong and Tax (as % of total tax revenue) in Tunisia?
Provide a short and direct response. 28.54. In the year 2005, what is the difference between the Tax (as % of total tax revenue) in Antigua and Barbuda and Tax (as % of total tax revenue) in Benin?
Your answer should be very brief. -8.55. In the year 2005, what is the difference between the Tax (as % of total tax revenue) in Antigua and Barbuda and Tax (as % of total tax revenue) in Hong Kong?
Your answer should be very brief. -49.09. In the year 2005, what is the difference between the Tax (as % of total tax revenue) in Antigua and Barbuda and Tax (as % of total tax revenue) in Tunisia?
Give a very brief answer. -22.49. In the year 2005, what is the difference between the Tax (as % of total tax revenue) of Benin and Tax (as % of total tax revenue) of Hong Kong?
Provide a succinct answer. -40.53. In the year 2005, what is the difference between the Tax (as % of total tax revenue) in Benin and Tax (as % of total tax revenue) in Tunisia?
Ensure brevity in your answer.  -13.94. In the year 2005, what is the difference between the Tax (as % of total tax revenue) in Hong Kong and Tax (as % of total tax revenue) in Tunisia?
Ensure brevity in your answer.  26.59. In the year 2006, what is the difference between the Tax (as % of total tax revenue) of Antigua and Barbuda and Tax (as % of total tax revenue) of Benin?
Provide a short and direct response. -2.47. In the year 2006, what is the difference between the Tax (as % of total tax revenue) in Antigua and Barbuda and Tax (as % of total tax revenue) in Hong Kong?
Your answer should be very brief. -41.13. In the year 2006, what is the difference between the Tax (as % of total tax revenue) of Antigua and Barbuda and Tax (as % of total tax revenue) of Tunisia?
Make the answer very short. -17.04. In the year 2006, what is the difference between the Tax (as % of total tax revenue) of Benin and Tax (as % of total tax revenue) of Hong Kong?
Ensure brevity in your answer.  -38.65. In the year 2006, what is the difference between the Tax (as % of total tax revenue) of Benin and Tax (as % of total tax revenue) of Tunisia?
Ensure brevity in your answer.  -14.56. In the year 2006, what is the difference between the Tax (as % of total tax revenue) of Hong Kong and Tax (as % of total tax revenue) of Tunisia?
Provide a succinct answer. 24.09. In the year 2007, what is the difference between the Tax (as % of total tax revenue) of Antigua and Barbuda and Tax (as % of total tax revenue) of Benin?
Your response must be concise. -6.49. In the year 2007, what is the difference between the Tax (as % of total tax revenue) of Antigua and Barbuda and Tax (as % of total tax revenue) of Hong Kong?
Keep it short and to the point. -42.97. In the year 2007, what is the difference between the Tax (as % of total tax revenue) in Antigua and Barbuda and Tax (as % of total tax revenue) in Tunisia?
Offer a very short reply. -24.29. In the year 2007, what is the difference between the Tax (as % of total tax revenue) of Benin and Tax (as % of total tax revenue) of Hong Kong?
Provide a short and direct response. -36.48. In the year 2007, what is the difference between the Tax (as % of total tax revenue) of Benin and Tax (as % of total tax revenue) of Tunisia?
Provide a short and direct response. -17.8. In the year 2007, what is the difference between the Tax (as % of total tax revenue) of Hong Kong and Tax (as % of total tax revenue) of Tunisia?
Provide a short and direct response. 18.68. In the year 2008, what is the difference between the Tax (as % of total tax revenue) in Antigua and Barbuda and Tax (as % of total tax revenue) in Benin?
Ensure brevity in your answer.  -4.62. In the year 2008, what is the difference between the Tax (as % of total tax revenue) in Antigua and Barbuda and Tax (as % of total tax revenue) in Hong Kong?
Your answer should be very brief. -50.8. In the year 2008, what is the difference between the Tax (as % of total tax revenue) of Antigua and Barbuda and Tax (as % of total tax revenue) of Tunisia?
Give a very brief answer. -24.15. In the year 2008, what is the difference between the Tax (as % of total tax revenue) in Benin and Tax (as % of total tax revenue) in Hong Kong?
Your response must be concise. -46.18. In the year 2008, what is the difference between the Tax (as % of total tax revenue) of Benin and Tax (as % of total tax revenue) of Tunisia?
Give a very brief answer. -19.53. In the year 2008, what is the difference between the Tax (as % of total tax revenue) in Hong Kong and Tax (as % of total tax revenue) in Tunisia?
Ensure brevity in your answer.  26.65. In the year 2009, what is the difference between the Tax (as % of total tax revenue) of Antigua and Barbuda and Tax (as % of total tax revenue) of Benin?
Ensure brevity in your answer.  -3.98. In the year 2009, what is the difference between the Tax (as % of total tax revenue) in Antigua and Barbuda and Tax (as % of total tax revenue) in Hong Kong?
Your answer should be compact. -41.49. In the year 2009, what is the difference between the Tax (as % of total tax revenue) in Antigua and Barbuda and Tax (as % of total tax revenue) in Tunisia?
Make the answer very short. -22.4. In the year 2009, what is the difference between the Tax (as % of total tax revenue) of Benin and Tax (as % of total tax revenue) of Hong Kong?
Ensure brevity in your answer.  -37.52. In the year 2009, what is the difference between the Tax (as % of total tax revenue) in Benin and Tax (as % of total tax revenue) in Tunisia?
Provide a short and direct response. -18.42. In the year 2009, what is the difference between the Tax (as % of total tax revenue) of Hong Kong and Tax (as % of total tax revenue) of Tunisia?
Provide a succinct answer. 19.1. What is the ratio of the Tax (as % of total tax revenue) of Antigua and Barbuda in 2002 to that in 2003?
Offer a very short reply. 1.06. What is the ratio of the Tax (as % of total tax revenue) in Benin in 2002 to that in 2003?
Give a very brief answer. 1.07. What is the ratio of the Tax (as % of total tax revenue) in Hong Kong in 2002 to that in 2003?
Your response must be concise. 1.02. What is the ratio of the Tax (as % of total tax revenue) in Tunisia in 2002 to that in 2003?
Offer a terse response. 0.96. What is the ratio of the Tax (as % of total tax revenue) of Antigua and Barbuda in 2002 to that in 2004?
Provide a short and direct response. 1.6. What is the ratio of the Tax (as % of total tax revenue) in Benin in 2002 to that in 2004?
Ensure brevity in your answer.  1.05. What is the ratio of the Tax (as % of total tax revenue) of Hong Kong in 2002 to that in 2004?
Keep it short and to the point. 1.01. What is the ratio of the Tax (as % of total tax revenue) in Tunisia in 2002 to that in 2004?
Provide a succinct answer. 0.96. What is the ratio of the Tax (as % of total tax revenue) of Antigua and Barbuda in 2002 to that in 2005?
Your response must be concise. 1.24. What is the ratio of the Tax (as % of total tax revenue) in Benin in 2002 to that in 2005?
Make the answer very short. 1.05. What is the ratio of the Tax (as % of total tax revenue) in Hong Kong in 2002 to that in 2005?
Ensure brevity in your answer.  0.98. What is the ratio of the Tax (as % of total tax revenue) of Tunisia in 2002 to that in 2005?
Your answer should be compact. 0.86. What is the ratio of the Tax (as % of total tax revenue) in Antigua and Barbuda in 2002 to that in 2006?
Ensure brevity in your answer.  0.88. What is the ratio of the Tax (as % of total tax revenue) in Benin in 2002 to that in 2006?
Your answer should be compact. 1.07. What is the ratio of the Tax (as % of total tax revenue) of Hong Kong in 2002 to that in 2006?
Your answer should be compact. 1.02. What is the ratio of the Tax (as % of total tax revenue) of Tunisia in 2002 to that in 2006?
Make the answer very short. 0.86. What is the ratio of the Tax (as % of total tax revenue) of Antigua and Barbuda in 2002 to that in 2007?
Provide a short and direct response. 1.19. What is the ratio of the Tax (as % of total tax revenue) of Benin in 2002 to that in 2007?
Your answer should be compact. 1.12. What is the ratio of the Tax (as % of total tax revenue) in Hong Kong in 2002 to that in 2007?
Your response must be concise. 1.07. What is the ratio of the Tax (as % of total tax revenue) of Tunisia in 2002 to that in 2007?
Your answer should be compact. 0.81. What is the ratio of the Tax (as % of total tax revenue) of Antigua and Barbuda in 2002 to that in 2008?
Provide a succinct answer. 1.08. What is the ratio of the Tax (as % of total tax revenue) of Benin in 2002 to that in 2008?
Your answer should be compact. 1.14. What is the ratio of the Tax (as % of total tax revenue) in Hong Kong in 2002 to that in 2008?
Your answer should be compact. 0.92. What is the ratio of the Tax (as % of total tax revenue) of Tunisia in 2002 to that in 2008?
Your answer should be compact. 0.78. What is the ratio of the Tax (as % of total tax revenue) of Antigua and Barbuda in 2002 to that in 2009?
Offer a terse response. 1.02. What is the ratio of the Tax (as % of total tax revenue) in Benin in 2002 to that in 2009?
Make the answer very short. 1.12. What is the ratio of the Tax (as % of total tax revenue) of Hong Kong in 2002 to that in 2009?
Your response must be concise. 1.06. What is the ratio of the Tax (as % of total tax revenue) in Tunisia in 2002 to that in 2009?
Ensure brevity in your answer.  0.8. What is the ratio of the Tax (as % of total tax revenue) of Antigua and Barbuda in 2003 to that in 2004?
Your response must be concise. 1.5. What is the ratio of the Tax (as % of total tax revenue) in Benin in 2003 to that in 2004?
Offer a very short reply. 0.98. What is the ratio of the Tax (as % of total tax revenue) in Hong Kong in 2003 to that in 2004?
Make the answer very short. 0.99. What is the ratio of the Tax (as % of total tax revenue) of Tunisia in 2003 to that in 2004?
Your response must be concise. 1. What is the ratio of the Tax (as % of total tax revenue) of Antigua and Barbuda in 2003 to that in 2005?
Ensure brevity in your answer.  1.17. What is the ratio of the Tax (as % of total tax revenue) in Benin in 2003 to that in 2005?
Ensure brevity in your answer.  0.98. What is the ratio of the Tax (as % of total tax revenue) of Tunisia in 2003 to that in 2005?
Your response must be concise. 0.9. What is the ratio of the Tax (as % of total tax revenue) in Antigua and Barbuda in 2003 to that in 2006?
Your answer should be compact. 0.83. What is the ratio of the Tax (as % of total tax revenue) in Benin in 2003 to that in 2006?
Offer a very short reply. 1. What is the ratio of the Tax (as % of total tax revenue) of Tunisia in 2003 to that in 2006?
Your answer should be very brief. 0.9. What is the ratio of the Tax (as % of total tax revenue) in Antigua and Barbuda in 2003 to that in 2007?
Provide a short and direct response. 1.12. What is the ratio of the Tax (as % of total tax revenue) in Benin in 2003 to that in 2007?
Provide a short and direct response. 1.04. What is the ratio of the Tax (as % of total tax revenue) in Hong Kong in 2003 to that in 2007?
Offer a very short reply. 1.05. What is the ratio of the Tax (as % of total tax revenue) in Tunisia in 2003 to that in 2007?
Your answer should be very brief. 0.84. What is the ratio of the Tax (as % of total tax revenue) of Antigua and Barbuda in 2003 to that in 2008?
Keep it short and to the point. 1.01. What is the ratio of the Tax (as % of total tax revenue) in Benin in 2003 to that in 2008?
Offer a very short reply. 1.06. What is the ratio of the Tax (as % of total tax revenue) of Hong Kong in 2003 to that in 2008?
Your answer should be compact. 0.91. What is the ratio of the Tax (as % of total tax revenue) in Tunisia in 2003 to that in 2008?
Your answer should be very brief. 0.82. What is the ratio of the Tax (as % of total tax revenue) in Antigua and Barbuda in 2003 to that in 2009?
Give a very brief answer. 0.96. What is the ratio of the Tax (as % of total tax revenue) in Benin in 2003 to that in 2009?
Provide a succinct answer. 1.04. What is the ratio of the Tax (as % of total tax revenue) in Hong Kong in 2003 to that in 2009?
Make the answer very short. 1.04. What is the ratio of the Tax (as % of total tax revenue) in Tunisia in 2003 to that in 2009?
Ensure brevity in your answer.  0.83. What is the ratio of the Tax (as % of total tax revenue) in Antigua and Barbuda in 2004 to that in 2005?
Offer a very short reply. 0.77. What is the ratio of the Tax (as % of total tax revenue) of Hong Kong in 2004 to that in 2005?
Keep it short and to the point. 0.97. What is the ratio of the Tax (as % of total tax revenue) of Tunisia in 2004 to that in 2005?
Give a very brief answer. 0.9. What is the ratio of the Tax (as % of total tax revenue) in Antigua and Barbuda in 2004 to that in 2006?
Provide a succinct answer. 0.55. What is the ratio of the Tax (as % of total tax revenue) in Benin in 2004 to that in 2006?
Make the answer very short. 1.01. What is the ratio of the Tax (as % of total tax revenue) of Hong Kong in 2004 to that in 2006?
Provide a succinct answer. 1.01. What is the ratio of the Tax (as % of total tax revenue) in Tunisia in 2004 to that in 2006?
Your answer should be very brief. 0.9. What is the ratio of the Tax (as % of total tax revenue) of Antigua and Barbuda in 2004 to that in 2007?
Keep it short and to the point. 0.74. What is the ratio of the Tax (as % of total tax revenue) in Benin in 2004 to that in 2007?
Offer a terse response. 1.06. What is the ratio of the Tax (as % of total tax revenue) of Hong Kong in 2004 to that in 2007?
Your answer should be very brief. 1.07. What is the ratio of the Tax (as % of total tax revenue) of Tunisia in 2004 to that in 2007?
Provide a short and direct response. 0.85. What is the ratio of the Tax (as % of total tax revenue) of Antigua and Barbuda in 2004 to that in 2008?
Make the answer very short. 0.67. What is the ratio of the Tax (as % of total tax revenue) in Benin in 2004 to that in 2008?
Offer a very short reply. 1.08. What is the ratio of the Tax (as % of total tax revenue) of Hong Kong in 2004 to that in 2008?
Your response must be concise. 0.92. What is the ratio of the Tax (as % of total tax revenue) in Tunisia in 2004 to that in 2008?
Offer a very short reply. 0.82. What is the ratio of the Tax (as % of total tax revenue) of Antigua and Barbuda in 2004 to that in 2009?
Keep it short and to the point. 0.64. What is the ratio of the Tax (as % of total tax revenue) of Benin in 2004 to that in 2009?
Offer a terse response. 1.06. What is the ratio of the Tax (as % of total tax revenue) of Hong Kong in 2004 to that in 2009?
Your answer should be compact. 1.05. What is the ratio of the Tax (as % of total tax revenue) of Tunisia in 2004 to that in 2009?
Provide a succinct answer. 0.83. What is the ratio of the Tax (as % of total tax revenue) in Antigua and Barbuda in 2005 to that in 2006?
Provide a succinct answer. 0.71. What is the ratio of the Tax (as % of total tax revenue) in Benin in 2005 to that in 2006?
Offer a very short reply. 1.02. What is the ratio of the Tax (as % of total tax revenue) of Tunisia in 2005 to that in 2006?
Make the answer very short. 1. What is the ratio of the Tax (as % of total tax revenue) in Antigua and Barbuda in 2005 to that in 2007?
Keep it short and to the point. 0.96. What is the ratio of the Tax (as % of total tax revenue) in Benin in 2005 to that in 2007?
Keep it short and to the point. 1.07. What is the ratio of the Tax (as % of total tax revenue) in Hong Kong in 2005 to that in 2007?
Ensure brevity in your answer.  1.1. What is the ratio of the Tax (as % of total tax revenue) in Tunisia in 2005 to that in 2007?
Offer a very short reply. 0.94. What is the ratio of the Tax (as % of total tax revenue) in Antigua and Barbuda in 2005 to that in 2008?
Your response must be concise. 0.87. What is the ratio of the Tax (as % of total tax revenue) in Benin in 2005 to that in 2008?
Offer a very short reply. 1.09. What is the ratio of the Tax (as % of total tax revenue) in Hong Kong in 2005 to that in 2008?
Offer a terse response. 0.94. What is the ratio of the Tax (as % of total tax revenue) of Tunisia in 2005 to that in 2008?
Offer a very short reply. 0.91. What is the ratio of the Tax (as % of total tax revenue) in Antigua and Barbuda in 2005 to that in 2009?
Give a very brief answer. 0.82. What is the ratio of the Tax (as % of total tax revenue) in Benin in 2005 to that in 2009?
Your answer should be very brief. 1.07. What is the ratio of the Tax (as % of total tax revenue) in Hong Kong in 2005 to that in 2009?
Your response must be concise. 1.08. What is the ratio of the Tax (as % of total tax revenue) in Tunisia in 2005 to that in 2009?
Make the answer very short. 0.92. What is the ratio of the Tax (as % of total tax revenue) of Antigua and Barbuda in 2006 to that in 2007?
Make the answer very short. 1.35. What is the ratio of the Tax (as % of total tax revenue) of Benin in 2006 to that in 2007?
Make the answer very short. 1.05. What is the ratio of the Tax (as % of total tax revenue) in Hong Kong in 2006 to that in 2007?
Your answer should be compact. 1.06. What is the ratio of the Tax (as % of total tax revenue) in Tunisia in 2006 to that in 2007?
Offer a terse response. 0.94. What is the ratio of the Tax (as % of total tax revenue) in Antigua and Barbuda in 2006 to that in 2008?
Give a very brief answer. 1.22. What is the ratio of the Tax (as % of total tax revenue) in Benin in 2006 to that in 2008?
Make the answer very short. 1.07. What is the ratio of the Tax (as % of total tax revenue) of Hong Kong in 2006 to that in 2008?
Make the answer very short. 0.91. What is the ratio of the Tax (as % of total tax revenue) in Tunisia in 2006 to that in 2008?
Offer a terse response. 0.91. What is the ratio of the Tax (as % of total tax revenue) of Antigua and Barbuda in 2006 to that in 2009?
Your answer should be very brief. 1.15. What is the ratio of the Tax (as % of total tax revenue) of Benin in 2006 to that in 2009?
Offer a terse response. 1.05. What is the ratio of the Tax (as % of total tax revenue) of Hong Kong in 2006 to that in 2009?
Provide a short and direct response. 1.04. What is the ratio of the Tax (as % of total tax revenue) in Tunisia in 2006 to that in 2009?
Your answer should be very brief. 0.93. What is the ratio of the Tax (as % of total tax revenue) of Antigua and Barbuda in 2007 to that in 2008?
Give a very brief answer. 0.91. What is the ratio of the Tax (as % of total tax revenue) in Benin in 2007 to that in 2008?
Provide a succinct answer. 1.02. What is the ratio of the Tax (as % of total tax revenue) in Hong Kong in 2007 to that in 2008?
Provide a short and direct response. 0.86. What is the ratio of the Tax (as % of total tax revenue) of Tunisia in 2007 to that in 2008?
Provide a short and direct response. 0.97. What is the ratio of the Tax (as % of total tax revenue) of Antigua and Barbuda in 2007 to that in 2009?
Offer a very short reply. 0.85. What is the ratio of the Tax (as % of total tax revenue) of Benin in 2007 to that in 2009?
Your answer should be compact. 1. What is the ratio of the Tax (as % of total tax revenue) in Hong Kong in 2007 to that in 2009?
Offer a terse response. 0.98. What is the ratio of the Tax (as % of total tax revenue) in Tunisia in 2007 to that in 2009?
Keep it short and to the point. 0.98. What is the ratio of the Tax (as % of total tax revenue) of Antigua and Barbuda in 2008 to that in 2009?
Provide a short and direct response. 0.94. What is the ratio of the Tax (as % of total tax revenue) in Benin in 2008 to that in 2009?
Make the answer very short. 0.98. What is the ratio of the Tax (as % of total tax revenue) in Hong Kong in 2008 to that in 2009?
Provide a succinct answer. 1.14. What is the ratio of the Tax (as % of total tax revenue) of Tunisia in 2008 to that in 2009?
Offer a terse response. 1.02. What is the difference between the highest and the second highest Tax (as % of total tax revenue) in Antigua and Barbuda?
Offer a terse response. 2.26. What is the difference between the highest and the second highest Tax (as % of total tax revenue) in Benin?
Your answer should be very brief. 1.05. What is the difference between the highest and the second highest Tax (as % of total tax revenue) of Hong Kong?
Ensure brevity in your answer.  3.79. What is the difference between the highest and the second highest Tax (as % of total tax revenue) of Tunisia?
Give a very brief answer. 0.76. What is the difference between the highest and the lowest Tax (as % of total tax revenue) of Antigua and Barbuda?
Your response must be concise. 8.78. What is the difference between the highest and the lowest Tax (as % of total tax revenue) of Benin?
Ensure brevity in your answer.  2.9. What is the difference between the highest and the lowest Tax (as % of total tax revenue) of Hong Kong?
Provide a succinct answer. 9.33. What is the difference between the highest and the lowest Tax (as % of total tax revenue) of Tunisia?
Ensure brevity in your answer.  8.77. 